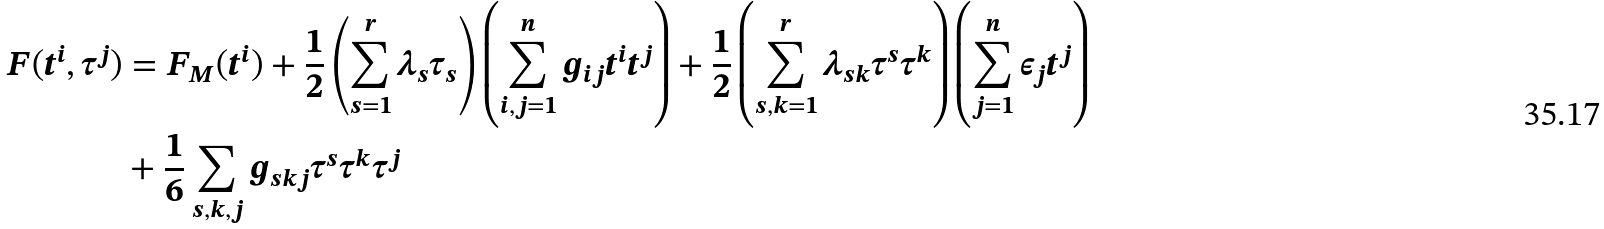<formula> <loc_0><loc_0><loc_500><loc_500>F ( t ^ { i } , { \tau } ^ { j } ) & = F _ { M } ( { t } ^ { i } ) + \frac { 1 } { 2 } \left ( \sum _ { s = 1 } ^ { r } \lambda _ { s } \tau _ { s } \right ) \left ( \sum _ { i , j = 1 } ^ { n } g _ { i j } t ^ { i } t ^ { j } \right ) + \frac { 1 } { 2 } \left ( \sum _ { s , k = 1 } ^ { r } \lambda _ { s k } \tau ^ { s } \tau ^ { k } \right ) \left ( \sum _ { j = 1 } ^ { n } \epsilon _ { j } t ^ { j } \right ) \\ & + \frac { 1 } { 6 } \sum _ { s , k , j } g _ { s k j } \tau ^ { s } \tau ^ { k } \tau ^ { j }</formula> 